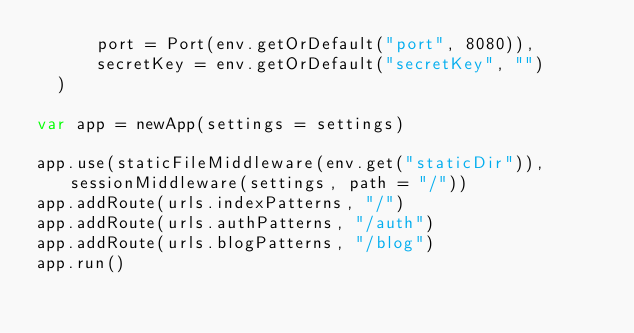<code> <loc_0><loc_0><loc_500><loc_500><_Nim_>      port = Port(env.getOrDefault("port", 8080)),
      secretKey = env.getOrDefault("secretKey", "")
  )

var app = newApp(settings = settings)

app.use(staticFileMiddleware(env.get("staticDir")), sessionMiddleware(settings, path = "/"))
app.addRoute(urls.indexPatterns, "/")
app.addRoute(urls.authPatterns, "/auth")
app.addRoute(urls.blogPatterns, "/blog")
app.run()
</code> 